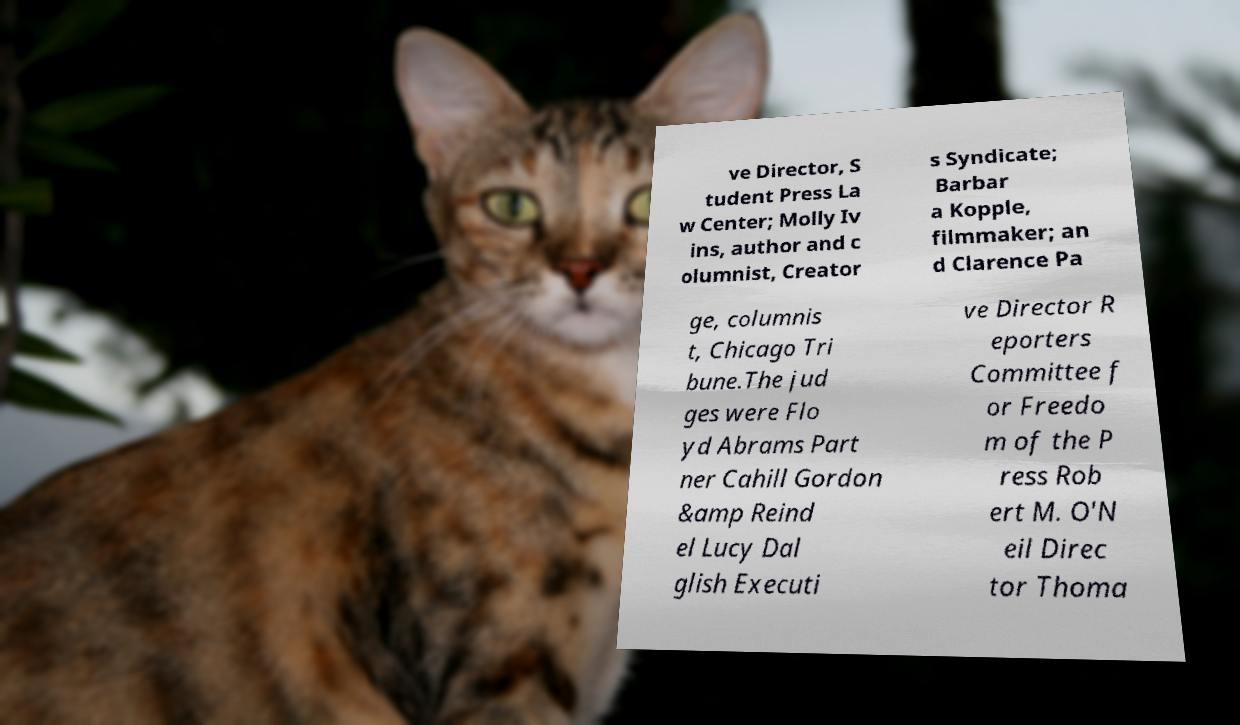Please read and relay the text visible in this image. What does it say? ve Director, S tudent Press La w Center; Molly Iv ins, author and c olumnist, Creator s Syndicate; Barbar a Kopple, filmmaker; an d Clarence Pa ge, columnis t, Chicago Tri bune.The jud ges were Flo yd Abrams Part ner Cahill Gordon &amp Reind el Lucy Dal glish Executi ve Director R eporters Committee f or Freedo m of the P ress Rob ert M. O'N eil Direc tor Thoma 